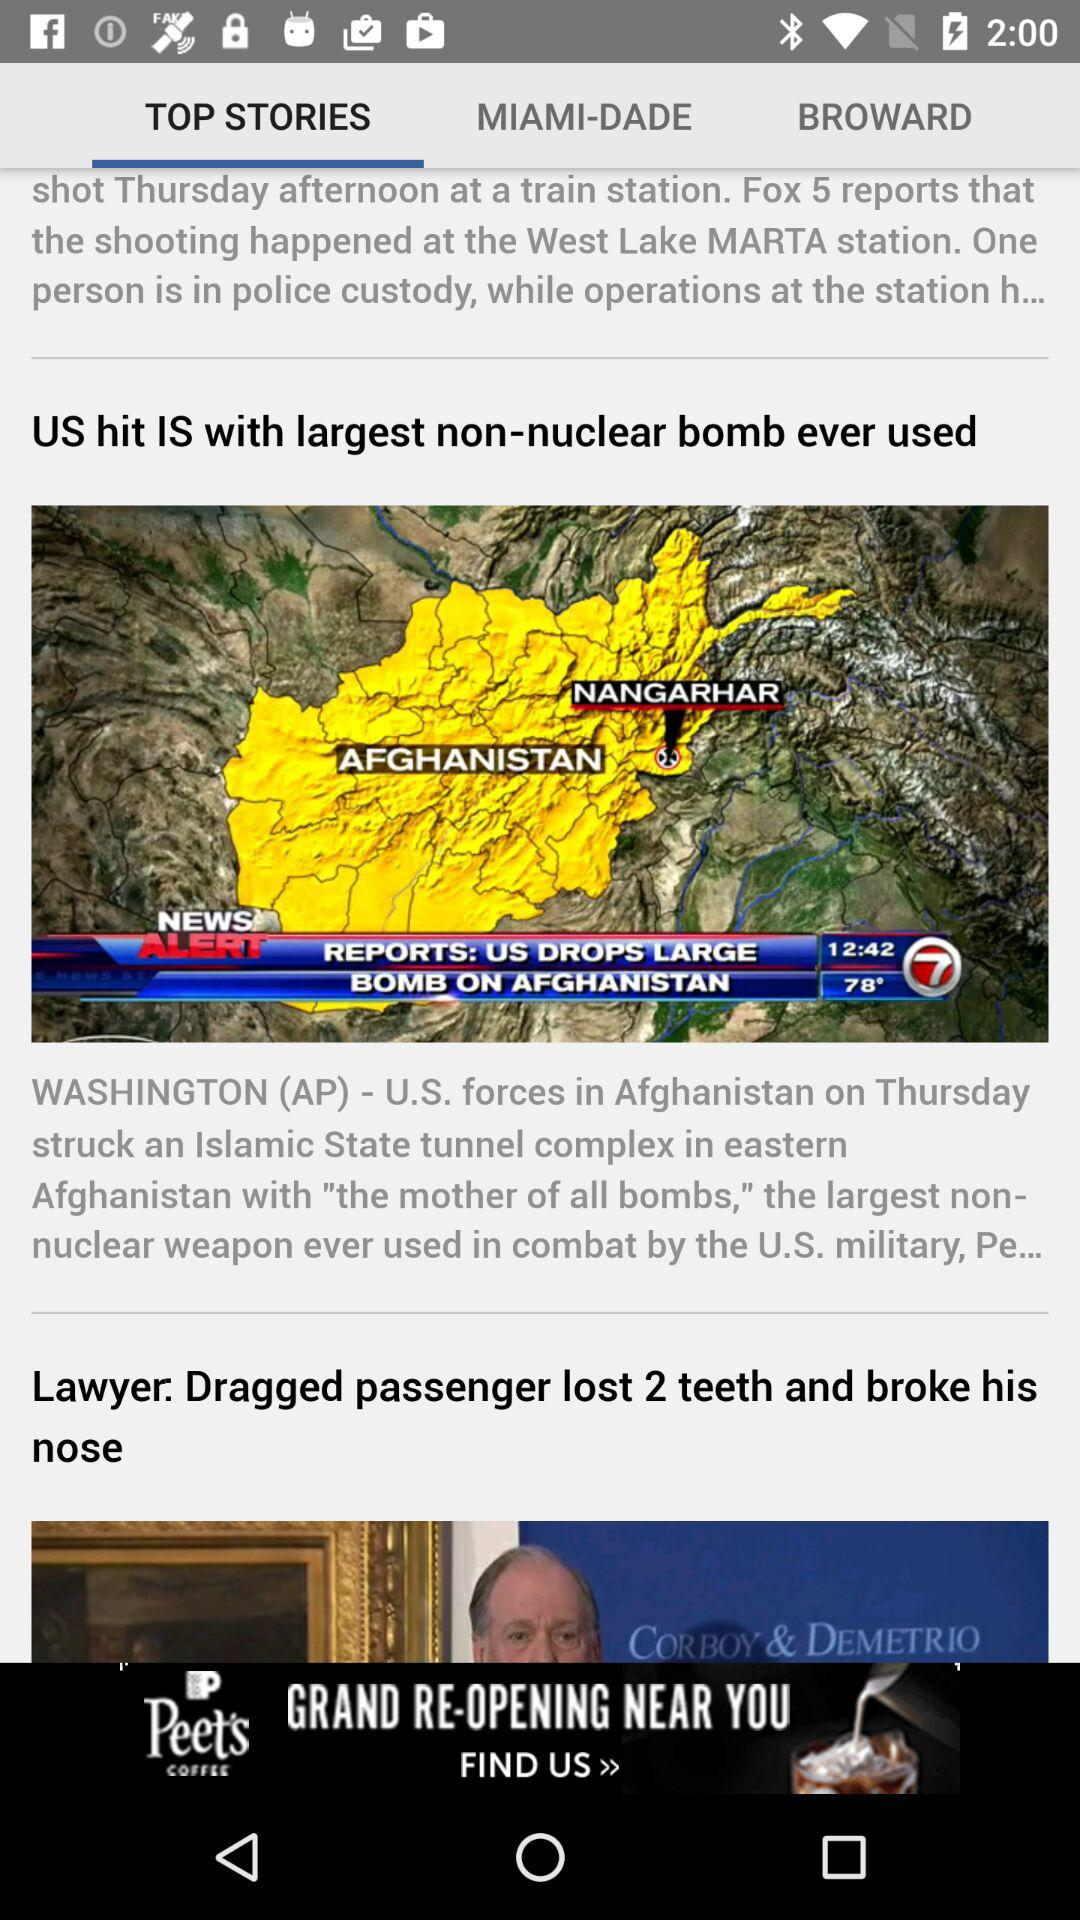How many articles are in "BROWARD"?
When the provided information is insufficient, respond with <no answer>. <no answer> 